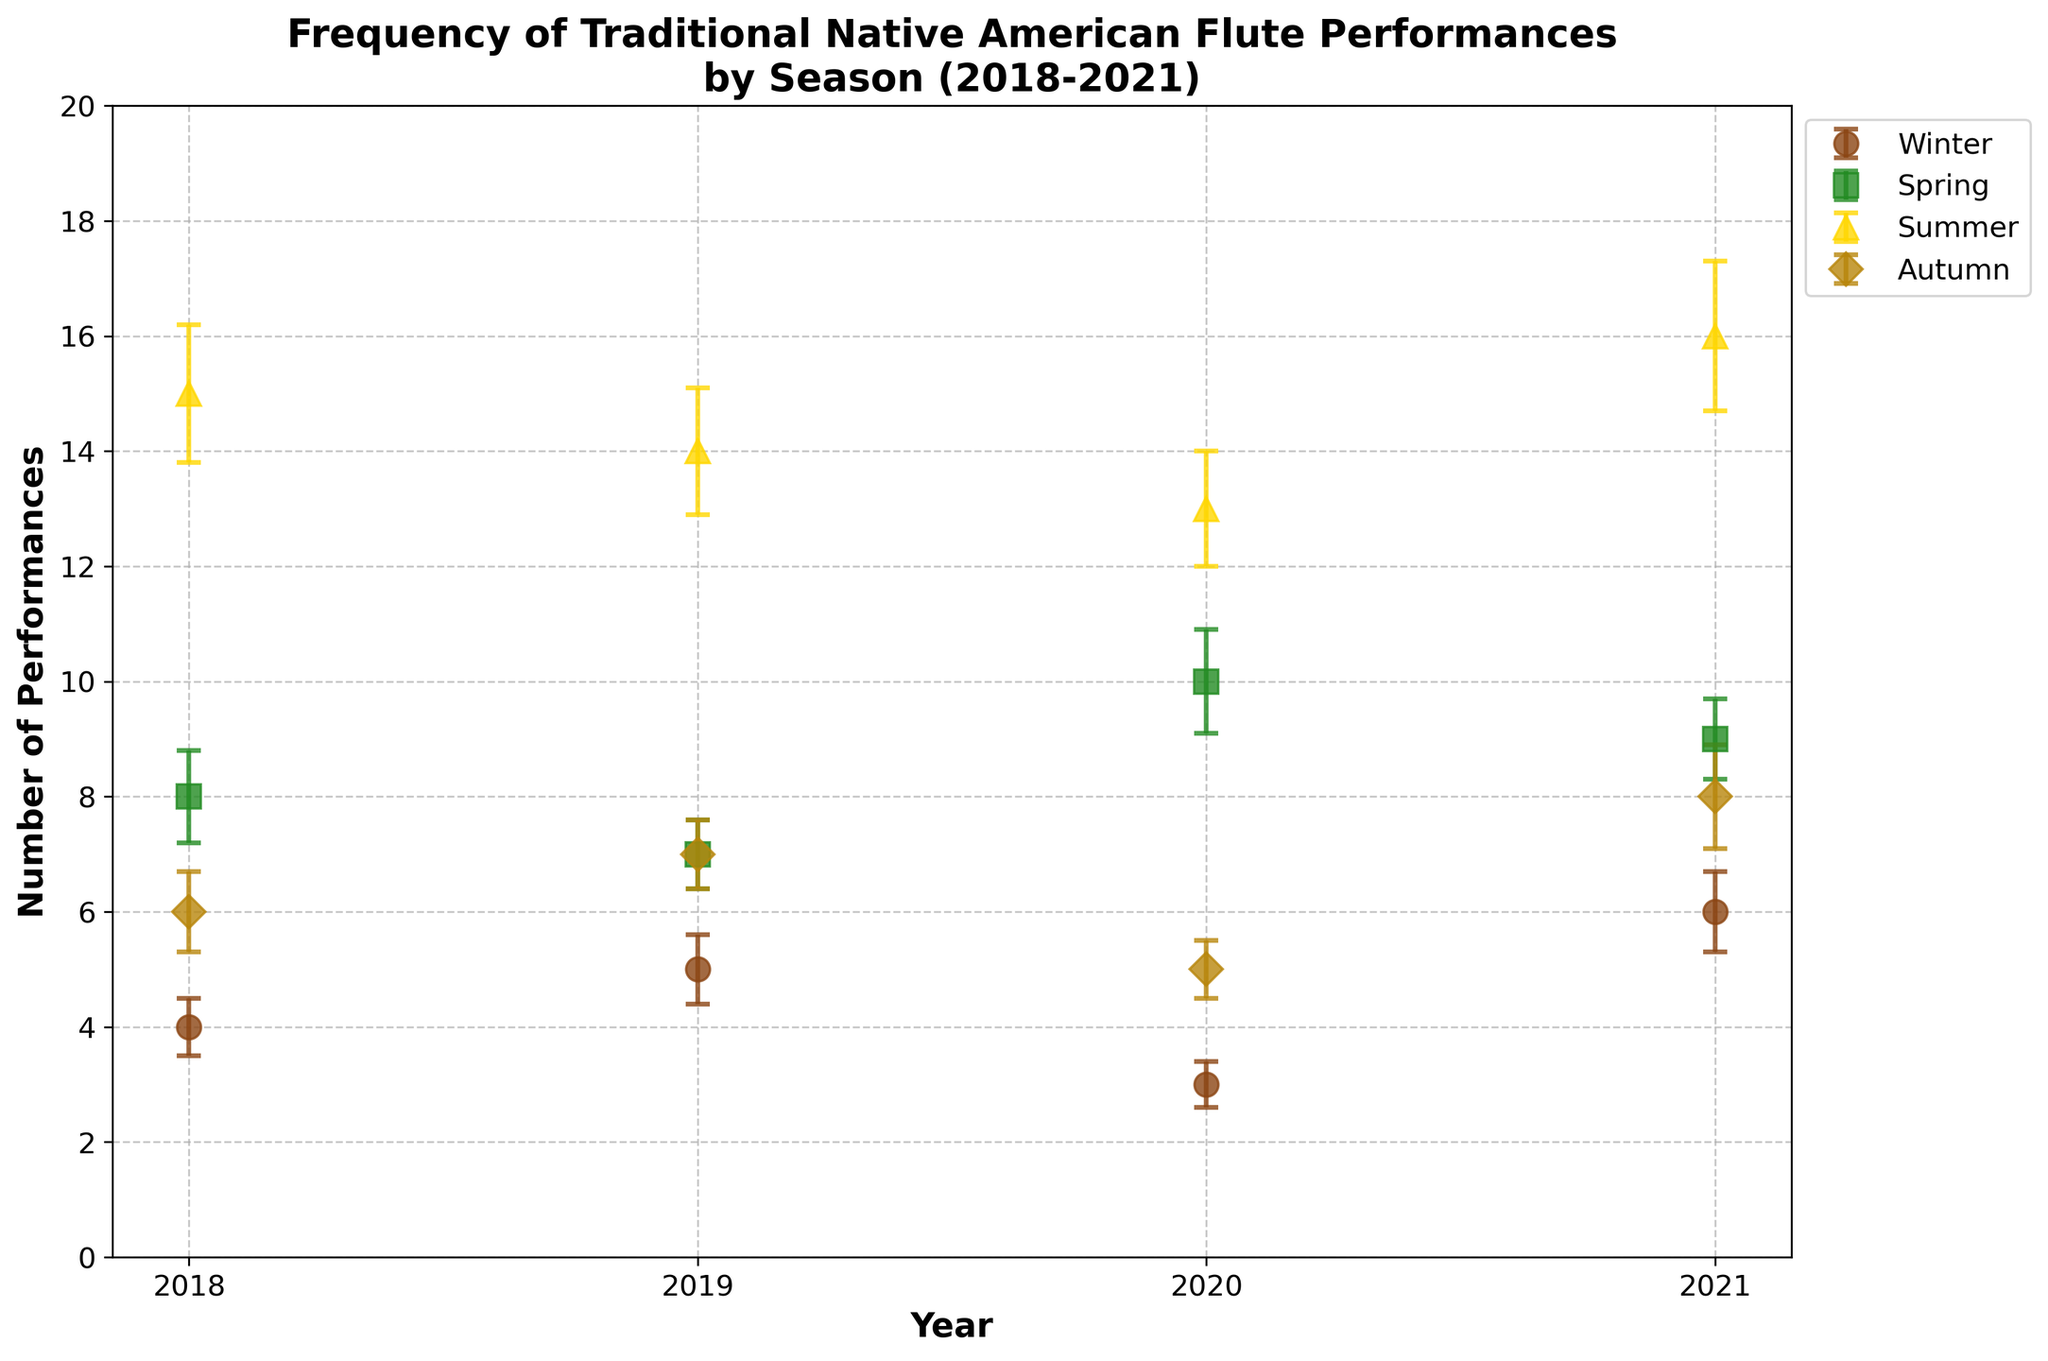What is the general trend in the number of performances during summer? By looking at the scatter plot, specifically at the Summer data points, you can observe that the number of performances has increased from 2018 to 2021.
Answer: The general trend is increasing How many winter performances were recorded in 2020? Locate the data point corresponding to Winter in 2020 on the scatter plot.
Answer: 3 performances Which season had the highest number of performances in 2019? Compare the performance counts for each season in 2019 and identify the highest.
Answer: Summer How does the number of Spring performances in 2020 compare to those in 2018? Look at the data points for Spring in 2020 and 2018, then compare the performance counts.
Answer: The performances in 2020 (10) were higher than in 2018 (8) What is the average number of Autumn performances over the years 2018-2021? Add the performance counts for Autumn from 2018 to 2021, then divide by the number of years. (6+7+5+8)/4
Answer: 6.5 During which year did Winter see the highest number of performances? Locate the Winter data points across all years and identify the year with the highest count.
Answer: 2021 For which year is the variability (confidence interval) in the number of Summer performances the largest? Examine the error bars for each Summer data point and identify the one with the largest error bar in 2021.
Answer: 2021 What can be inferred about the overall seasonal trend in performances from 2018 to 2021? Analyze the trend lines for each season and observe any general patterns. Generally, Summer has the highest and most consistent frequency, while Winter and Autumn show more variability. Despite this, most seasons tend to either stay stable or increase in performance frequency over the years.
Answer: Summers consistently have the highest performances 